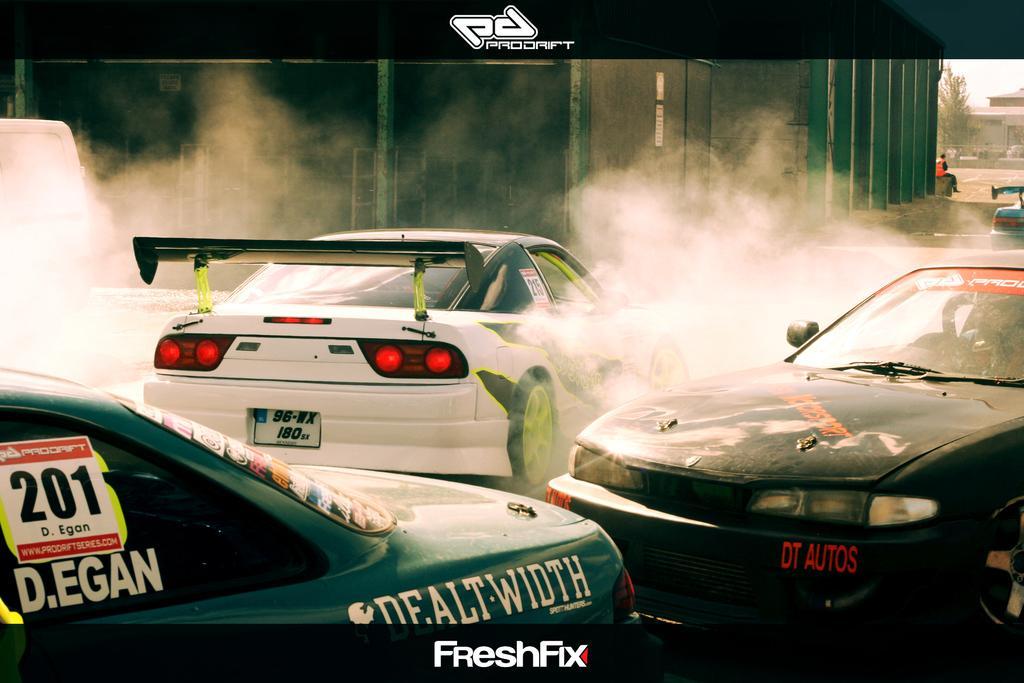Could you give a brief overview of what you see in this image? In this picture we can see three sports car in the front. Beside there is a smoke. In the background we can see the black wall. 